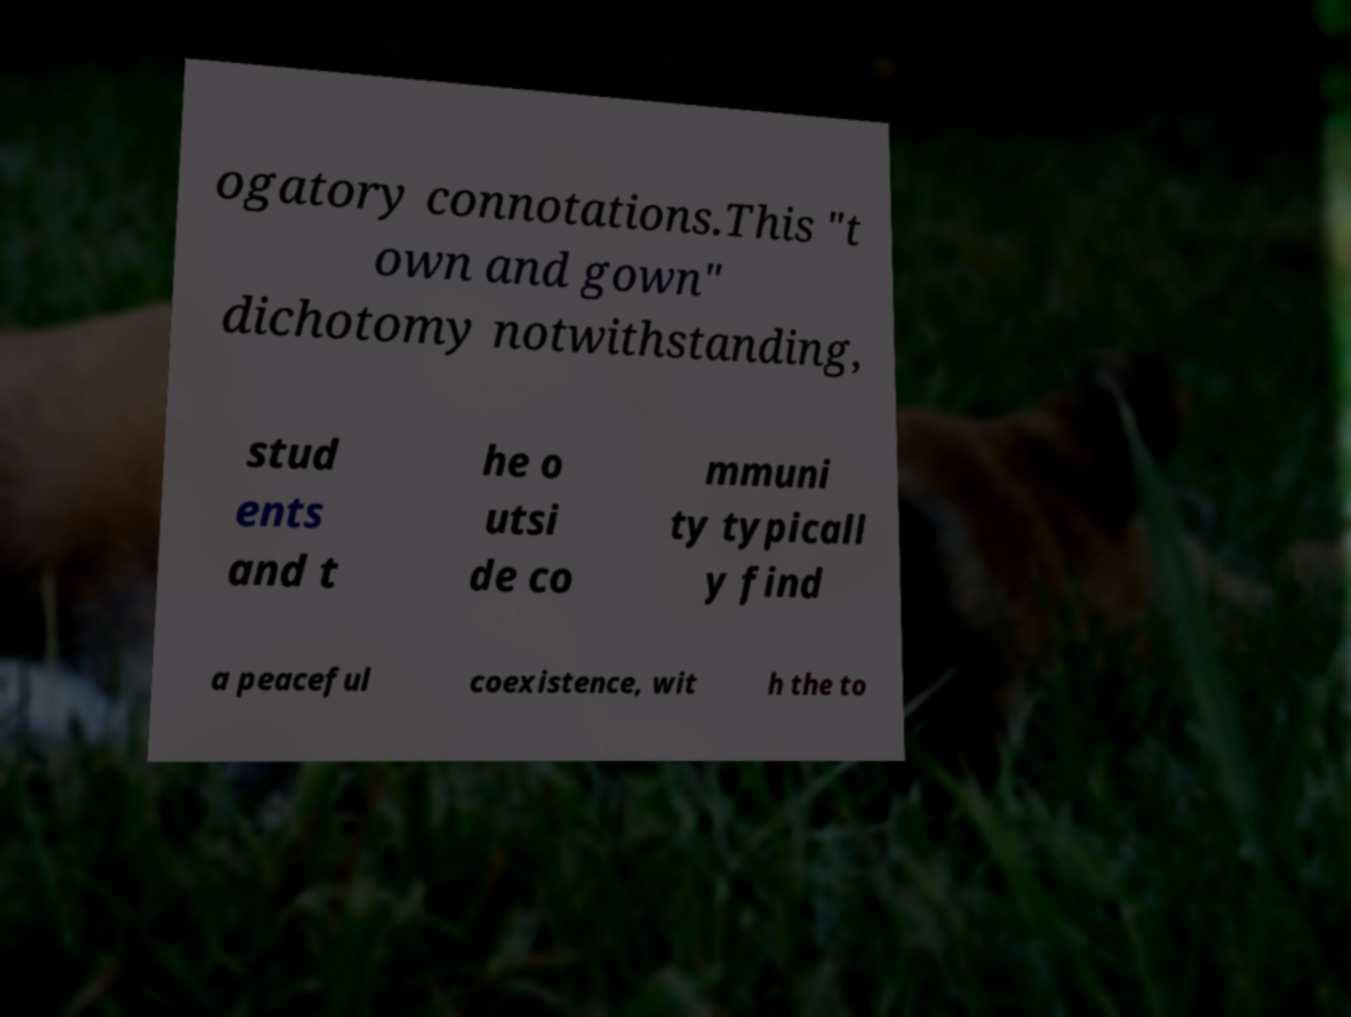Please identify and transcribe the text found in this image. ogatory connotations.This "t own and gown" dichotomy notwithstanding, stud ents and t he o utsi de co mmuni ty typicall y find a peaceful coexistence, wit h the to 